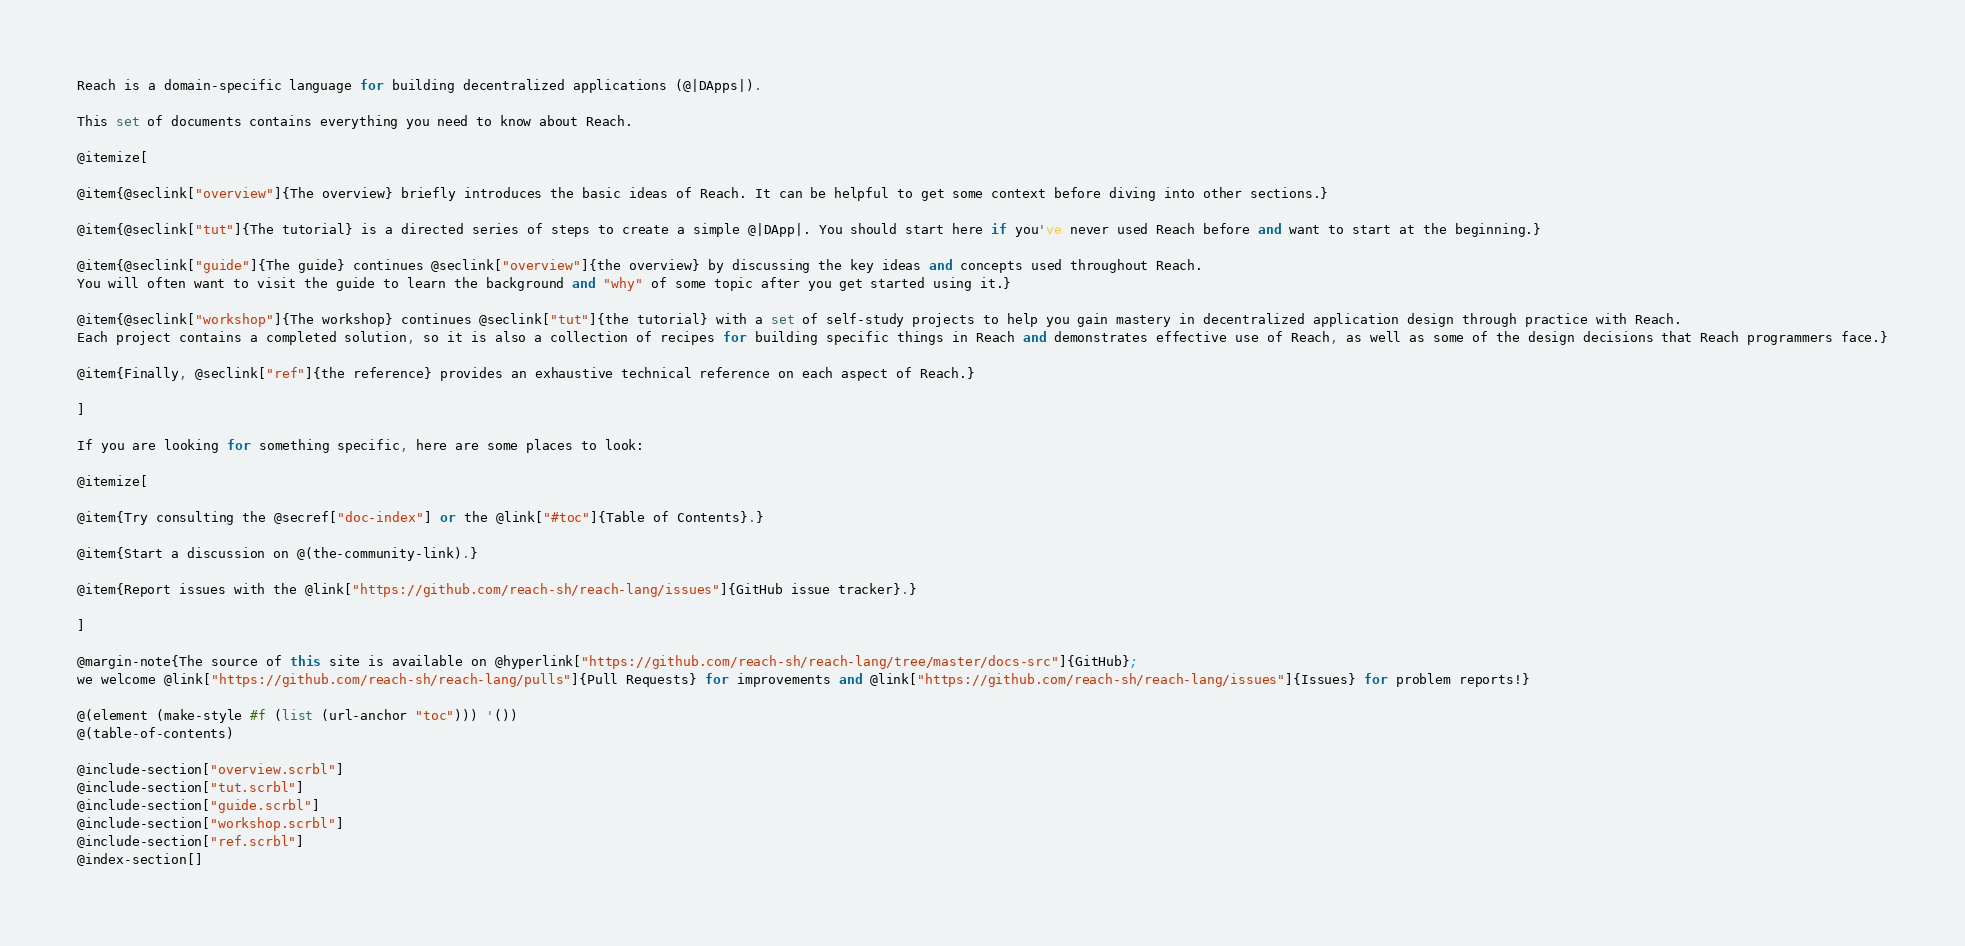<code> <loc_0><loc_0><loc_500><loc_500><_Racket_>
Reach is a domain-specific language for building decentralized applications (@|DApps|).

This set of documents contains everything you need to know about Reach.

@itemize[

@item{@seclink["overview"]{The overview} briefly introduces the basic ideas of Reach. It can be helpful to get some context before diving into other sections.}

@item{@seclink["tut"]{The tutorial} is a directed series of steps to create a simple @|DApp|. You should start here if you've never used Reach before and want to start at the beginning.}

@item{@seclink["guide"]{The guide} continues @seclink["overview"]{the overview} by discussing the key ideas and concepts used throughout Reach.
You will often want to visit the guide to learn the background and "why" of some topic after you get started using it.}

@item{@seclink["workshop"]{The workshop} continues @seclink["tut"]{the tutorial} with a set of self-study projects to help you gain mastery in decentralized application design through practice with Reach.
Each project contains a completed solution, so it is also a collection of recipes for building specific things in Reach and demonstrates effective use of Reach, as well as some of the design decisions that Reach programmers face.}

@item{Finally, @seclink["ref"]{the reference} provides an exhaustive technical reference on each aspect of Reach.}

]

If you are looking for something specific, here are some places to look:

@itemize[

@item{Try consulting the @secref["doc-index"] or the @link["#toc"]{Table of Contents}.}

@item{Start a discussion on @(the-community-link).}

@item{Report issues with the @link["https://github.com/reach-sh/reach-lang/issues"]{GitHub issue tracker}.}

]

@margin-note{The source of this site is available on @hyperlink["https://github.com/reach-sh/reach-lang/tree/master/docs-src"]{GitHub};
we welcome @link["https://github.com/reach-sh/reach-lang/pulls"]{Pull Requests} for improvements and @link["https://github.com/reach-sh/reach-lang/issues"]{Issues} for problem reports!}

@(element (make-style #f (list (url-anchor "toc"))) '())
@(table-of-contents)

@include-section["overview.scrbl"]
@include-section["tut.scrbl"]
@include-section["guide.scrbl"]
@include-section["workshop.scrbl"]
@include-section["ref.scrbl"]
@index-section[]
</code> 